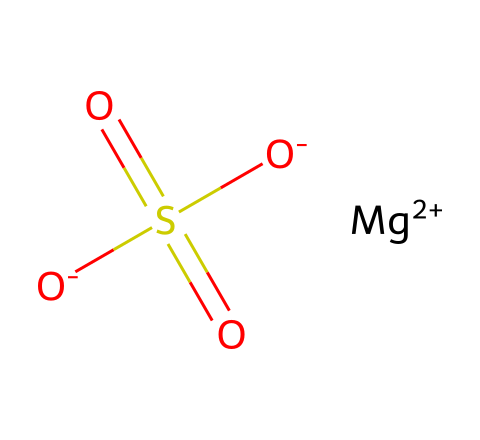What is the chemical name of the compound represented? The SMILES representation contains "Mg", "S", and "O", indicating the presence of magnesium, sulfur, and oxygen. This corresponds to the chemical name magnesium sulfate.
Answer: magnesium sulfate How many oxygen atoms are present in this chemical structure? The structure includes "O" three times, indicating three oxygen atoms are attached to the sulfur atom.
Answer: three What is the oxidation state of magnesium in this compound? Magnesium is represented as "Mg+2" in the SMILES notation, indicating that it has a +2 oxidation state.
Answer: +2 How many total atoms are present in the molecular structure? Counting the individual elements from the SMILES: 1 magnesium, 1 sulfur, and 4 oxygen atoms yield a total of 6 atoms.
Answer: six Does this compound act as an electrolyte? Magnesium sulfate dissociates into ions (Mg2+ and SO4^2-) in solution, which is the characteristic behavior of electrolytes.
Answer: yes What is the significance of magnesium sulfate in diplomatic stress relief? Magnesium sulfate is known for its calming properties, especially when dissolved in water, making it beneficial for stress relief in intense situations, including negotiations.
Answer: calming properties 